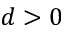<formula> <loc_0><loc_0><loc_500><loc_500>d > 0</formula> 